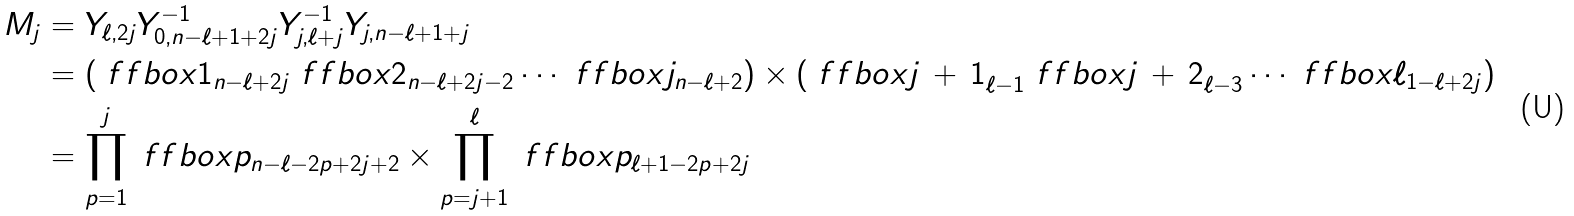<formula> <loc_0><loc_0><loc_500><loc_500>M _ { j } & = Y _ { \ell , 2 j } Y _ { 0 , n - \ell + 1 + 2 j } ^ { - 1 } Y _ { j , \ell + j } ^ { - 1 } Y _ { j , n - \ell + 1 + j } \\ & = \left ( \ f f b o x { 1 } _ { n - \ell + 2 j } \ f f b o x { 2 } _ { n - \ell + 2 j - 2 } \cdots \ f f b o x { j } _ { n - \ell + 2 } \right ) \times \left ( \ f f b o x { j \, + \, 1 } _ { \ell - 1 } \ f f b o x { j \, + \, 2 } _ { \ell - 3 } \cdots \ f f b o x { \ell } _ { 1 - \ell + 2 j } \right ) \\ & = \prod _ { p = 1 } ^ { j } \ f f b o x { p } _ { n - \ell - 2 p + 2 j + 2 } \times \prod _ { p = j + 1 } ^ { \ell } \ f f b o x { p } _ { \ell + 1 - 2 p + 2 j }</formula> 